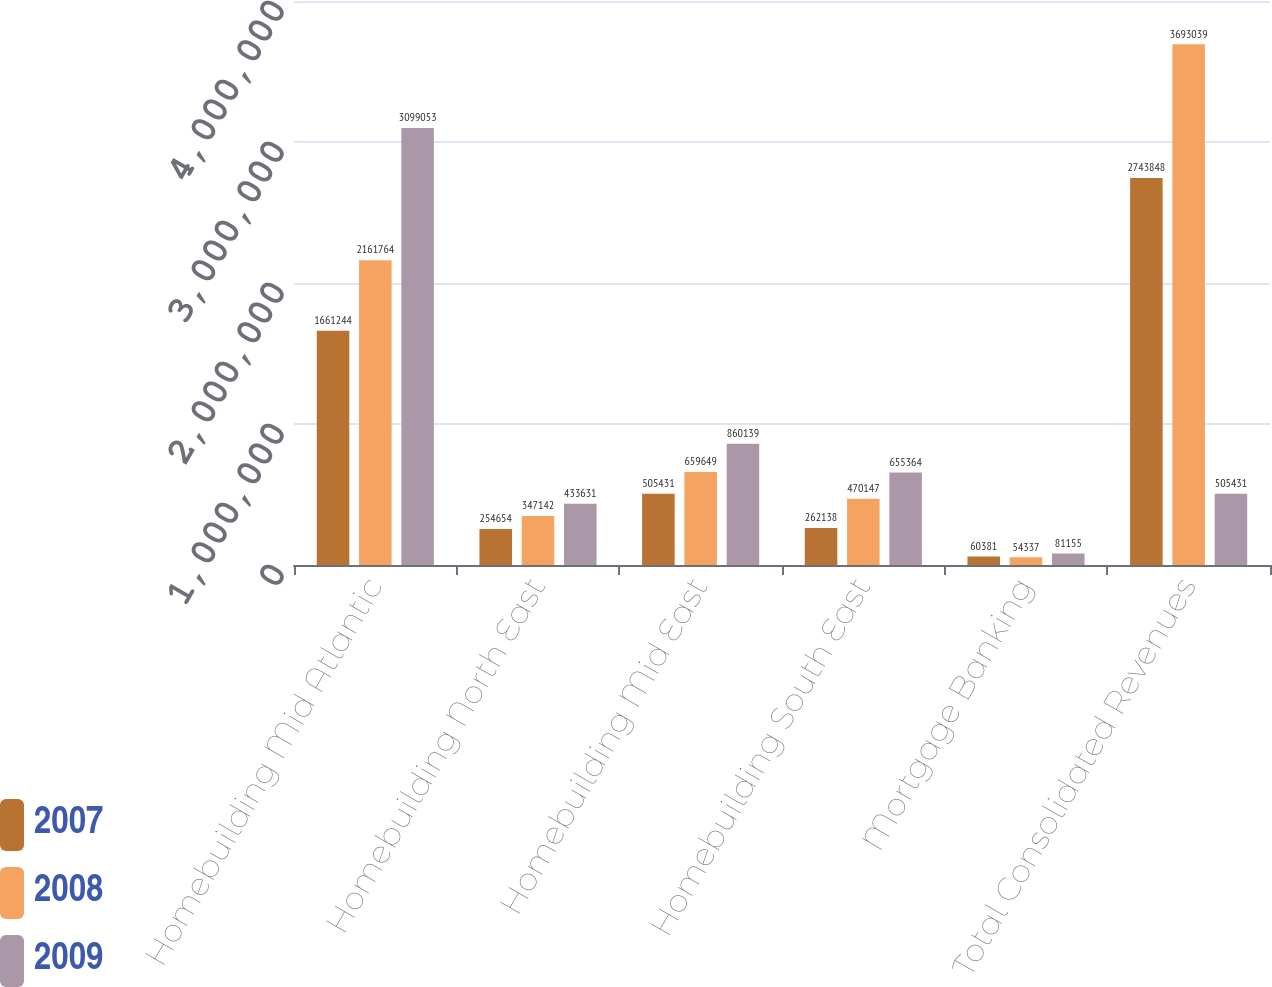Convert chart to OTSL. <chart><loc_0><loc_0><loc_500><loc_500><stacked_bar_chart><ecel><fcel>Homebuilding Mid Atlantic<fcel>Homebuilding North East<fcel>Homebuilding Mid East<fcel>Homebuilding South East<fcel>Mortgage Banking<fcel>Total Consolidated Revenues<nl><fcel>2007<fcel>1.66124e+06<fcel>254654<fcel>505431<fcel>262138<fcel>60381<fcel>2.74385e+06<nl><fcel>2008<fcel>2.16176e+06<fcel>347142<fcel>659649<fcel>470147<fcel>54337<fcel>3.69304e+06<nl><fcel>2009<fcel>3.09905e+06<fcel>433631<fcel>860139<fcel>655364<fcel>81155<fcel>505431<nl></chart> 